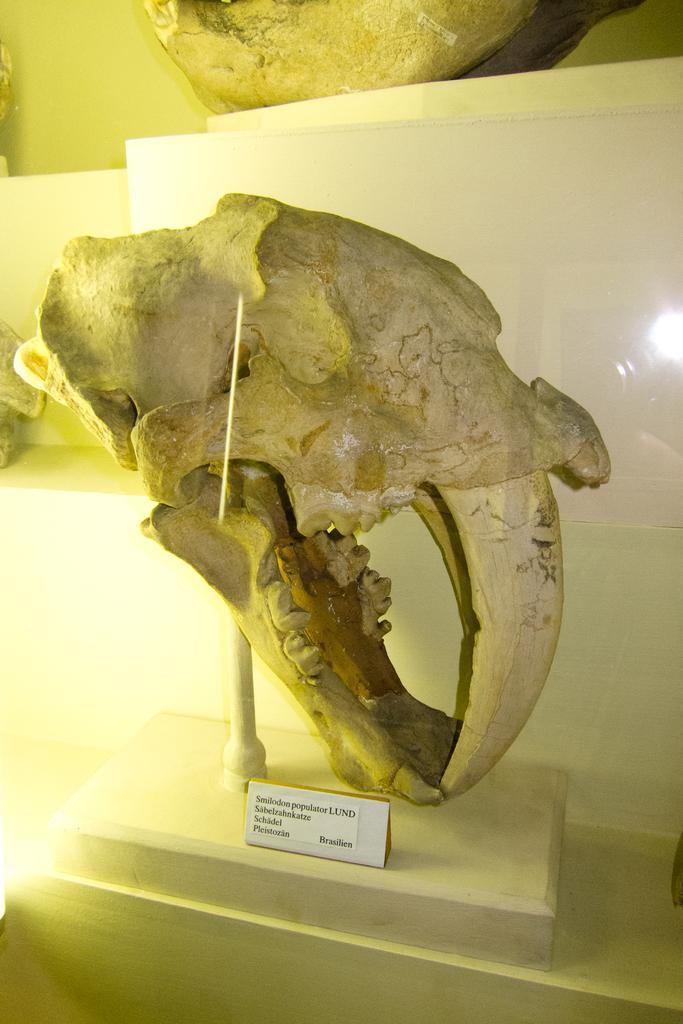In one or two sentences, can you explain what this image depicts? In the center of this picture we can see the skull of an animal placed on an object and we can see the text on the paper which is attached to the object. At the top we can see the wall and some other objects. 